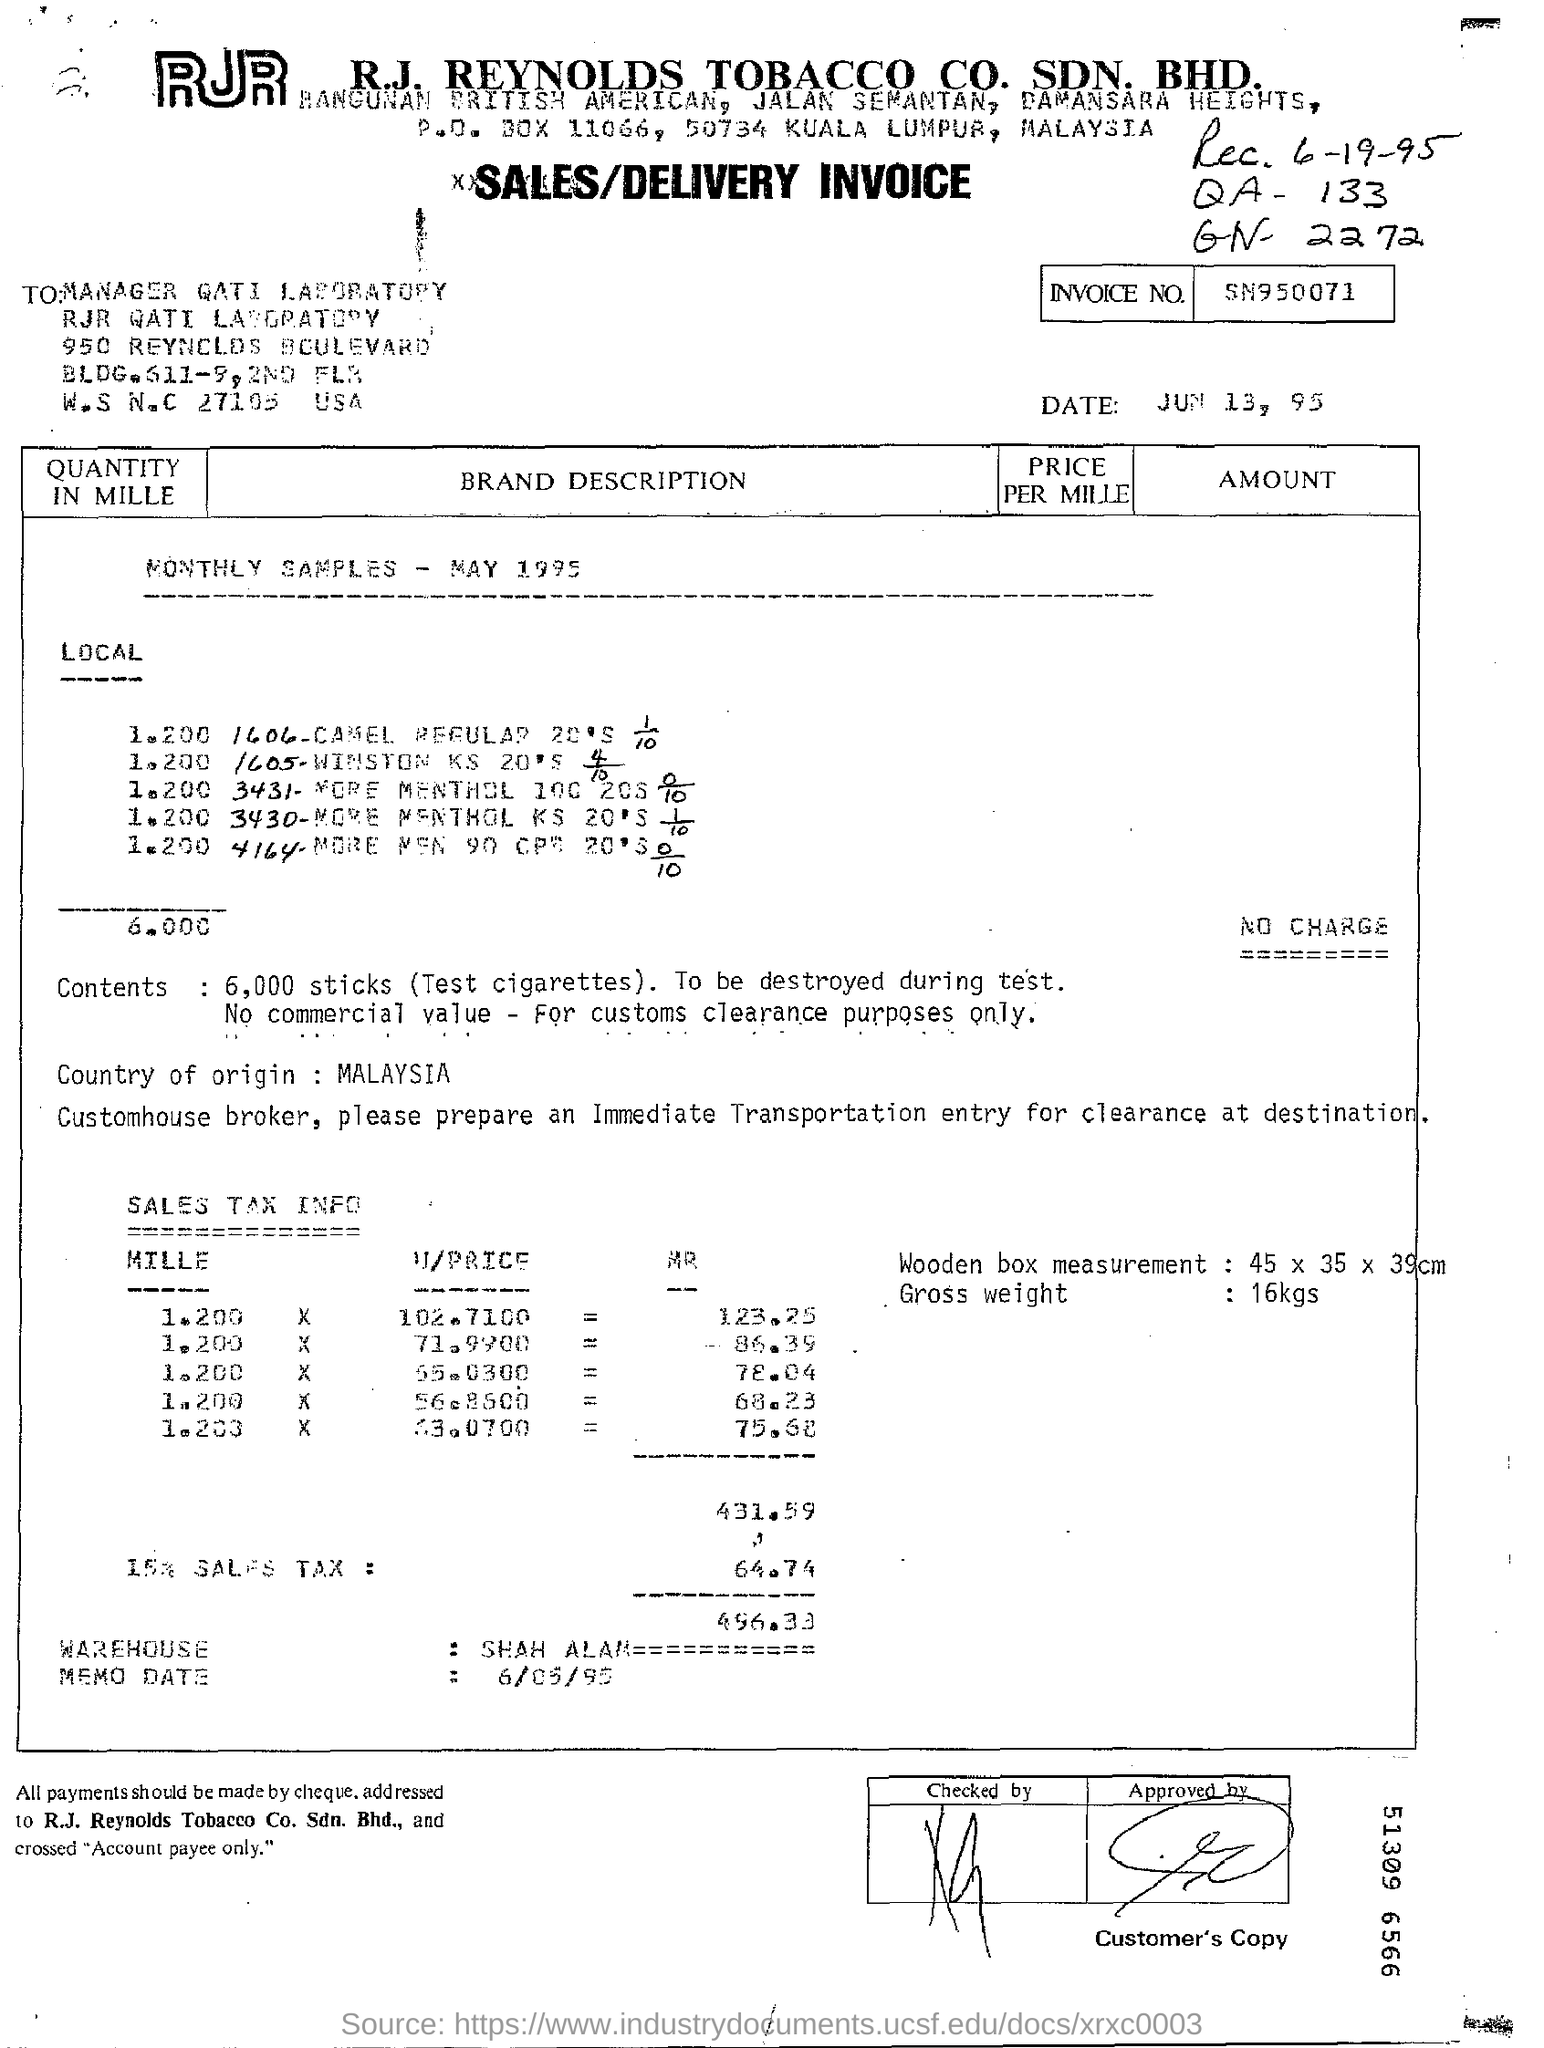Specify some key components in this picture. The gross weight of the items is 16 kilograms. The country of origin is Malaysia. The invoice is dated June 13, 1995. The invoice number is SN950071... This is a sales/delivery invoice type of documentation. 